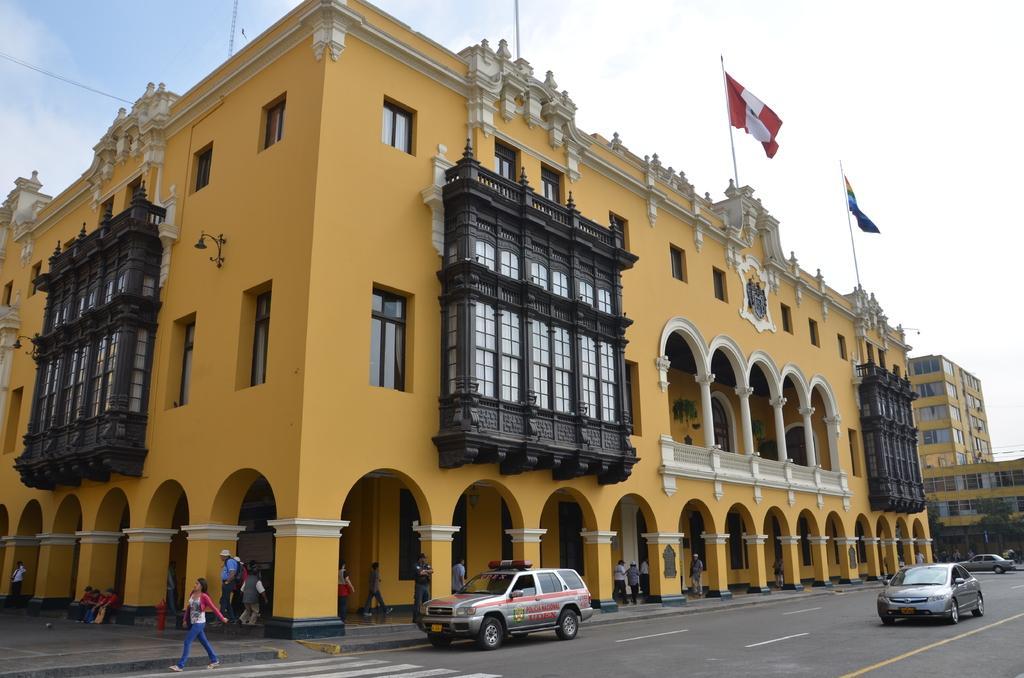Can you describe this image briefly? In this image we can see some buildings with windows and pillars. We can also see some people standing under a building. We can also see some vehicles on the road and the sky which looks cloudy. 